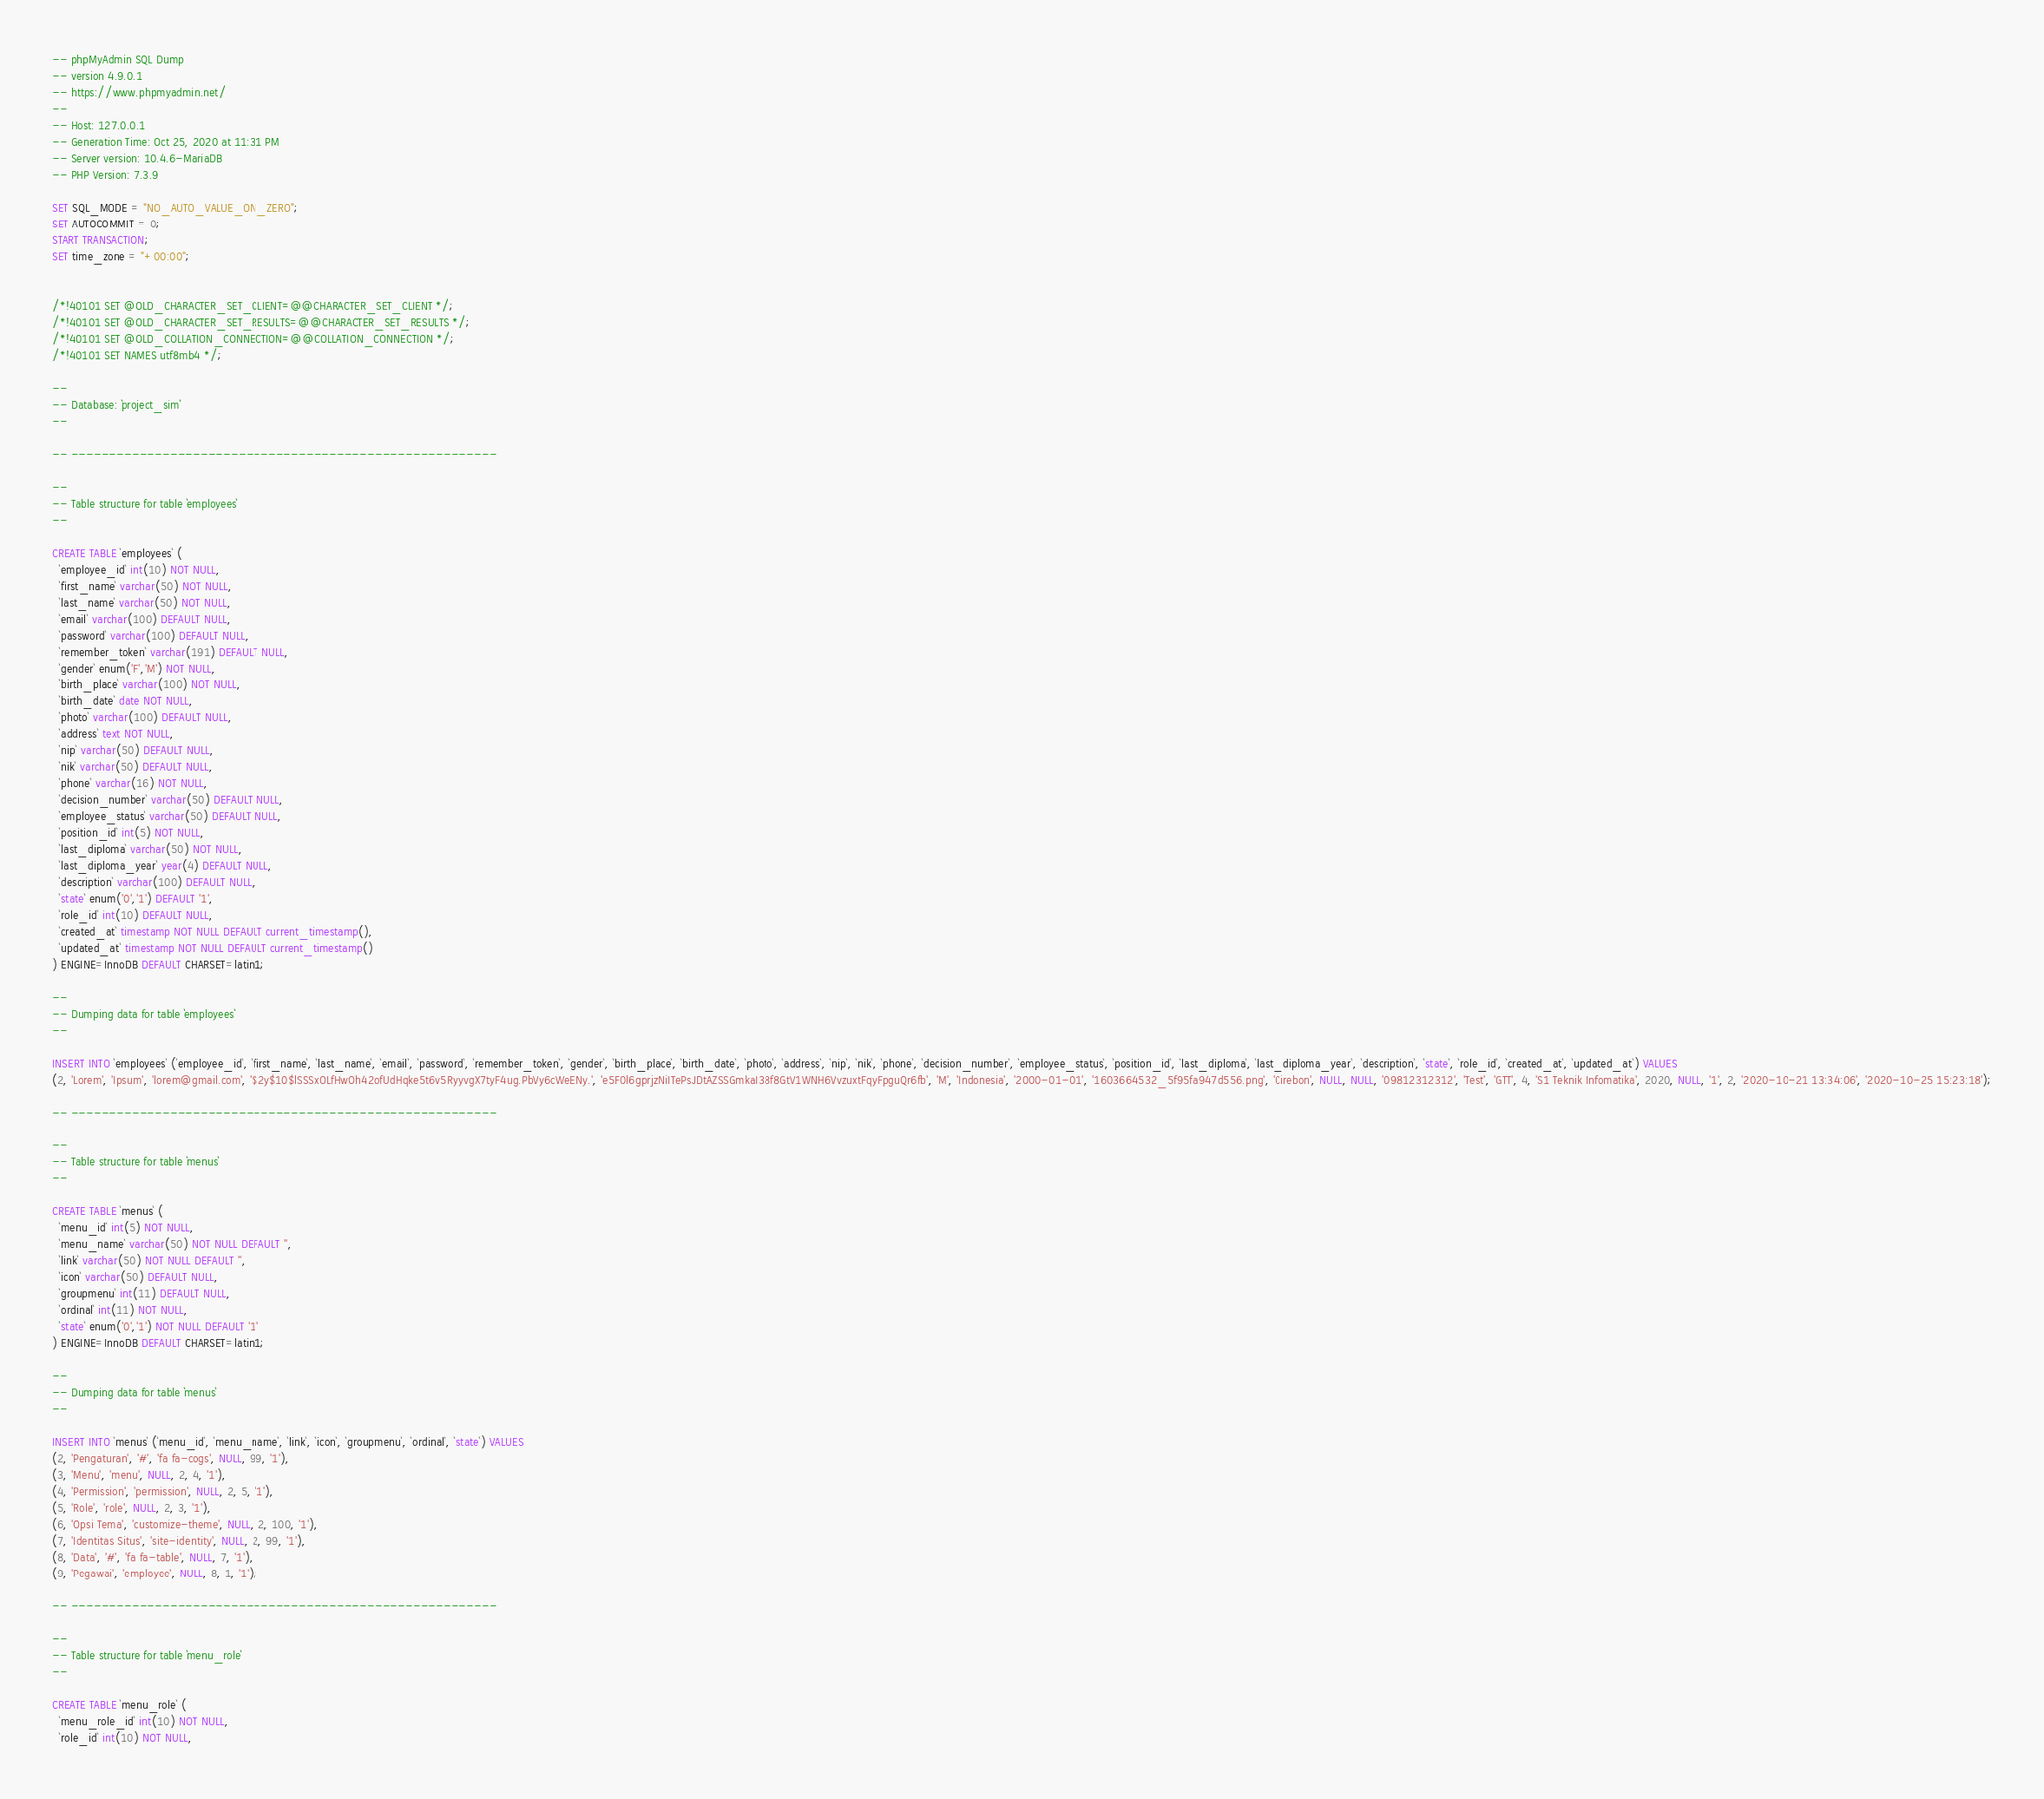Convert code to text. <code><loc_0><loc_0><loc_500><loc_500><_SQL_>-- phpMyAdmin SQL Dump
-- version 4.9.0.1
-- https://www.phpmyadmin.net/
--
-- Host: 127.0.0.1
-- Generation Time: Oct 25, 2020 at 11:31 PM
-- Server version: 10.4.6-MariaDB
-- PHP Version: 7.3.9

SET SQL_MODE = "NO_AUTO_VALUE_ON_ZERO";
SET AUTOCOMMIT = 0;
START TRANSACTION;
SET time_zone = "+00:00";


/*!40101 SET @OLD_CHARACTER_SET_CLIENT=@@CHARACTER_SET_CLIENT */;
/*!40101 SET @OLD_CHARACTER_SET_RESULTS=@@CHARACTER_SET_RESULTS */;
/*!40101 SET @OLD_COLLATION_CONNECTION=@@COLLATION_CONNECTION */;
/*!40101 SET NAMES utf8mb4 */;

--
-- Database: `project_sim`
--

-- --------------------------------------------------------

--
-- Table structure for table `employees`
--

CREATE TABLE `employees` (
  `employee_id` int(10) NOT NULL,
  `first_name` varchar(50) NOT NULL,
  `last_name` varchar(50) NOT NULL,
  `email` varchar(100) DEFAULT NULL,
  `password` varchar(100) DEFAULT NULL,
  `remember_token` varchar(191) DEFAULT NULL,
  `gender` enum('F','M') NOT NULL,
  `birth_place` varchar(100) NOT NULL,
  `birth_date` date NOT NULL,
  `photo` varchar(100) DEFAULT NULL,
  `address` text NOT NULL,
  `nip` varchar(50) DEFAULT NULL,
  `nik` varchar(50) DEFAULT NULL,
  `phone` varchar(16) NOT NULL,
  `decision_number` varchar(50) DEFAULT NULL,
  `employee_status` varchar(50) DEFAULT NULL,
  `position_id` int(5) NOT NULL,
  `last_diploma` varchar(50) NOT NULL,
  `last_diploma_year` year(4) DEFAULT NULL,
  `description` varchar(100) DEFAULT NULL,
  `state` enum('0','1') DEFAULT '1',
  `role_id` int(10) DEFAULT NULL,
  `created_at` timestamp NOT NULL DEFAULT current_timestamp(),
  `updated_at` timestamp NOT NULL DEFAULT current_timestamp()
) ENGINE=InnoDB DEFAULT CHARSET=latin1;

--
-- Dumping data for table `employees`
--

INSERT INTO `employees` (`employee_id`, `first_name`, `last_name`, `email`, `password`, `remember_token`, `gender`, `birth_place`, `birth_date`, `photo`, `address`, `nip`, `nik`, `phone`, `decision_number`, `employee_status`, `position_id`, `last_diploma`, `last_diploma_year`, `description`, `state`, `role_id`, `created_at`, `updated_at`) VALUES
(2, 'Lorem', 'Ipsum', 'lorem@gmail.com', '$2y$10$lSSSxOLfHwOh42ofUdHqke5t6v5RyyvgX7tyF4ug.PbVy6cWeENy.', 'e5F0l6gprjzNiITePsJDtAZSSGmkaI38f8GtV1WNH6VvzuxtFqyFpguQr6fb', 'M', 'Indonesia', '2000-01-01', '1603664532_5f95fa947d556.png', 'Cirebon', NULL, NULL, '09812312312', 'Test', 'GTT', 4, 'S1 Teknik Infomatika', 2020, NULL, '1', 2, '2020-10-21 13:34:06', '2020-10-25 15:23:18');

-- --------------------------------------------------------

--
-- Table structure for table `menus`
--

CREATE TABLE `menus` (
  `menu_id` int(5) NOT NULL,
  `menu_name` varchar(50) NOT NULL DEFAULT '',
  `link` varchar(50) NOT NULL DEFAULT '',
  `icon` varchar(50) DEFAULT NULL,
  `groupmenu` int(11) DEFAULT NULL,
  `ordinal` int(11) NOT NULL,
  `state` enum('0','1') NOT NULL DEFAULT '1'
) ENGINE=InnoDB DEFAULT CHARSET=latin1;

--
-- Dumping data for table `menus`
--

INSERT INTO `menus` (`menu_id`, `menu_name`, `link`, `icon`, `groupmenu`, `ordinal`, `state`) VALUES
(2, 'Pengaturan', '#', 'fa fa-cogs', NULL, 99, '1'),
(3, 'Menu', 'menu', NULL, 2, 4, '1'),
(4, 'Permission', 'permission', NULL, 2, 5, '1'),
(5, 'Role', 'role', NULL, 2, 3, '1'),
(6, 'Opsi Tema', 'customize-theme', NULL, 2, 100, '1'),
(7, 'Identitas Situs', 'site-identity', NULL, 2, 99, '1'),
(8, 'Data', '#', 'fa fa-table', NULL, 7, '1'),
(9, 'Pegawai', 'employee', NULL, 8, 1, '1');

-- --------------------------------------------------------

--
-- Table structure for table `menu_role`
--

CREATE TABLE `menu_role` (
  `menu_role_id` int(10) NOT NULL,
  `role_id` int(10) NOT NULL,</code> 